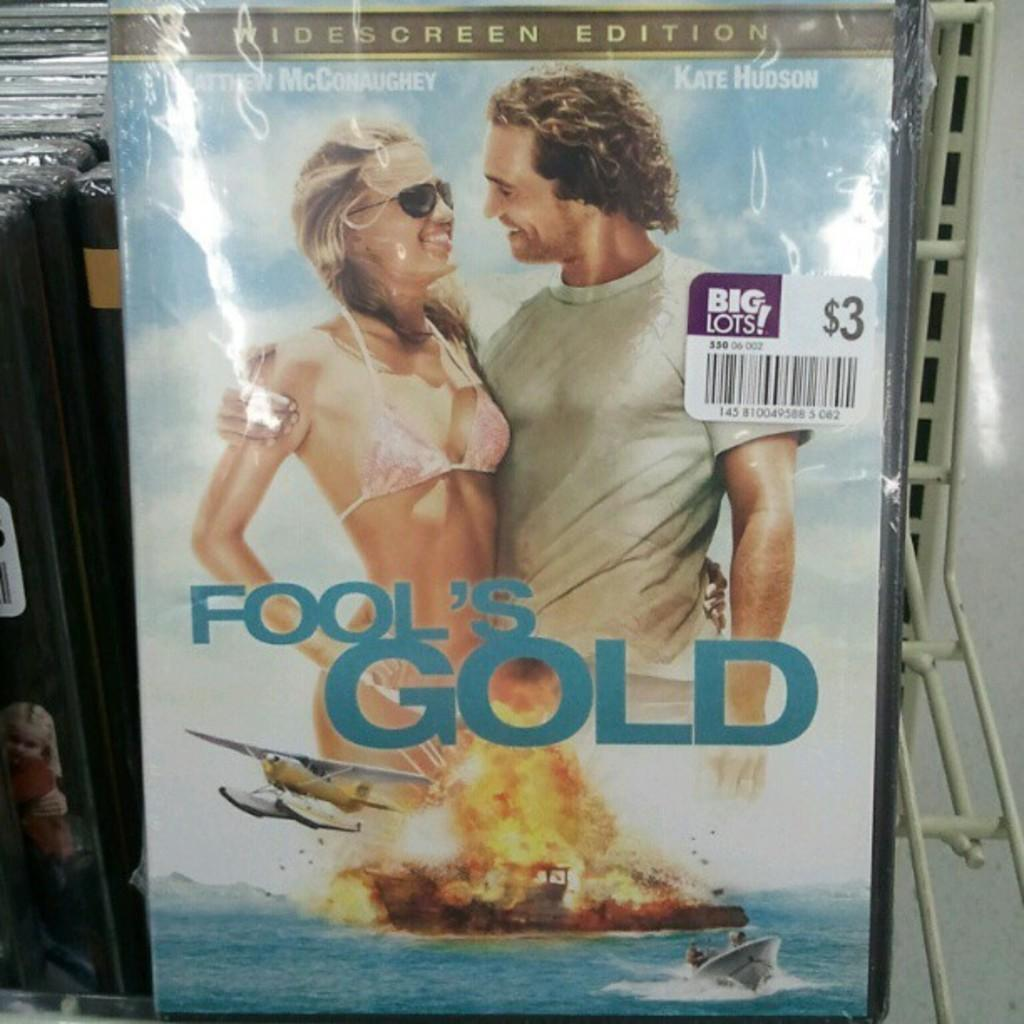<image>
Offer a succinct explanation of the picture presented. A wide screen edition of fool's gold with a big lots sticker on the right of it. 